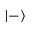Convert formula to latex. <formula><loc_0><loc_0><loc_500><loc_500>| - \rangle</formula> 